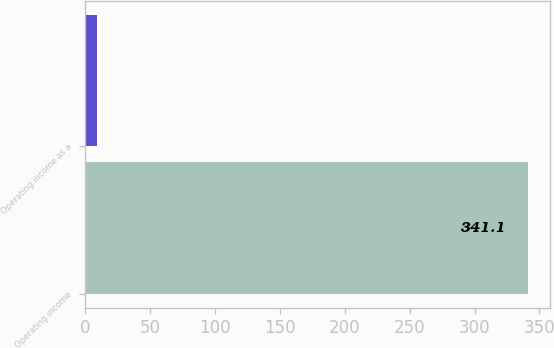Convert chart to OTSL. <chart><loc_0><loc_0><loc_500><loc_500><bar_chart><fcel>Operating income<fcel>Operating income as a<nl><fcel>341.1<fcel>9.3<nl></chart> 